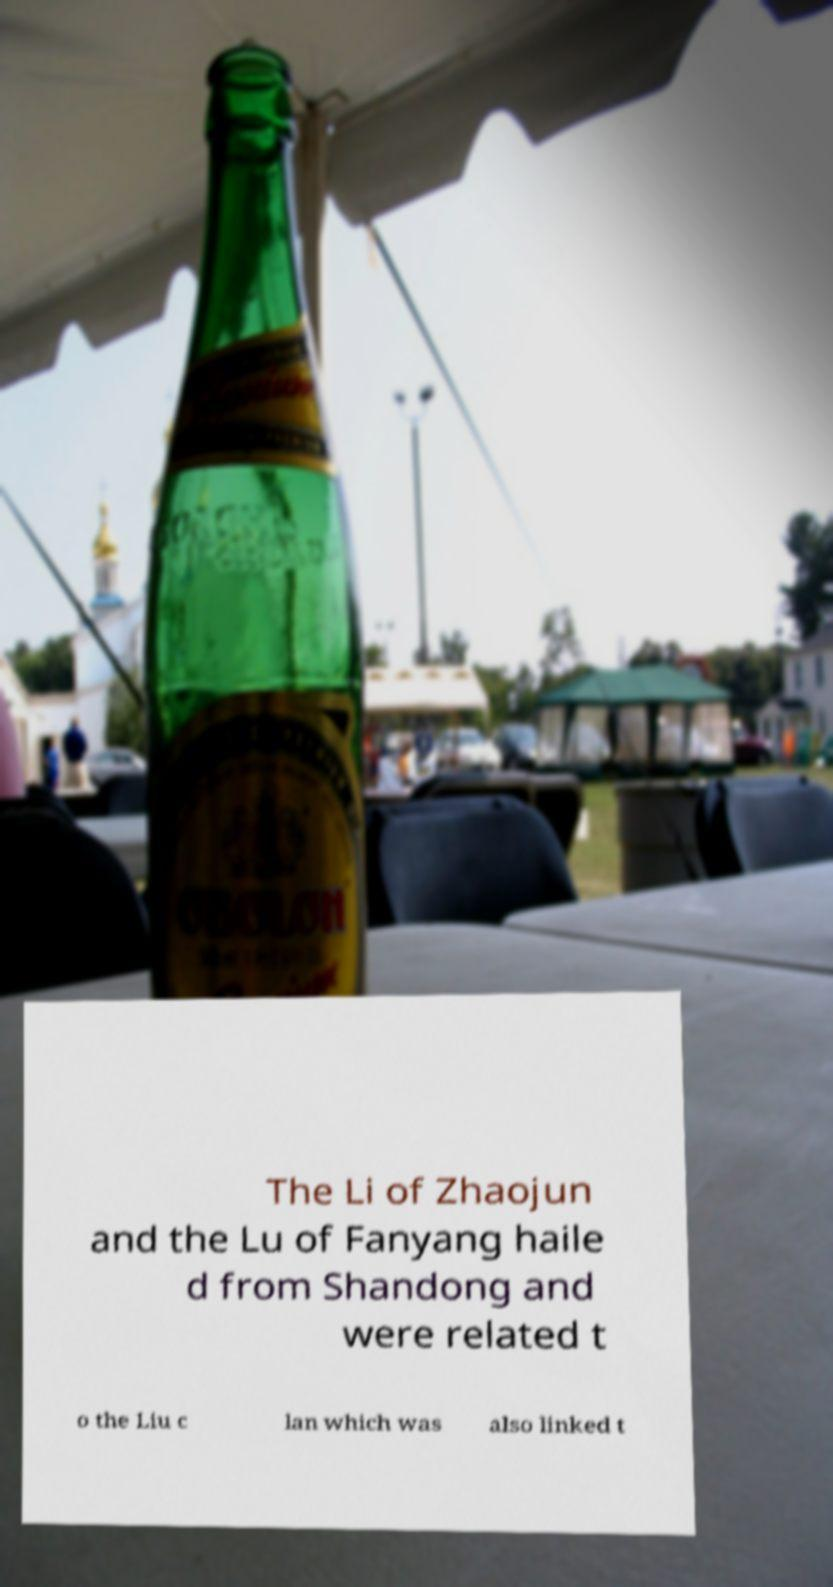Can you accurately transcribe the text from the provided image for me? The Li of Zhaojun and the Lu of Fanyang haile d from Shandong and were related t o the Liu c lan which was also linked t 